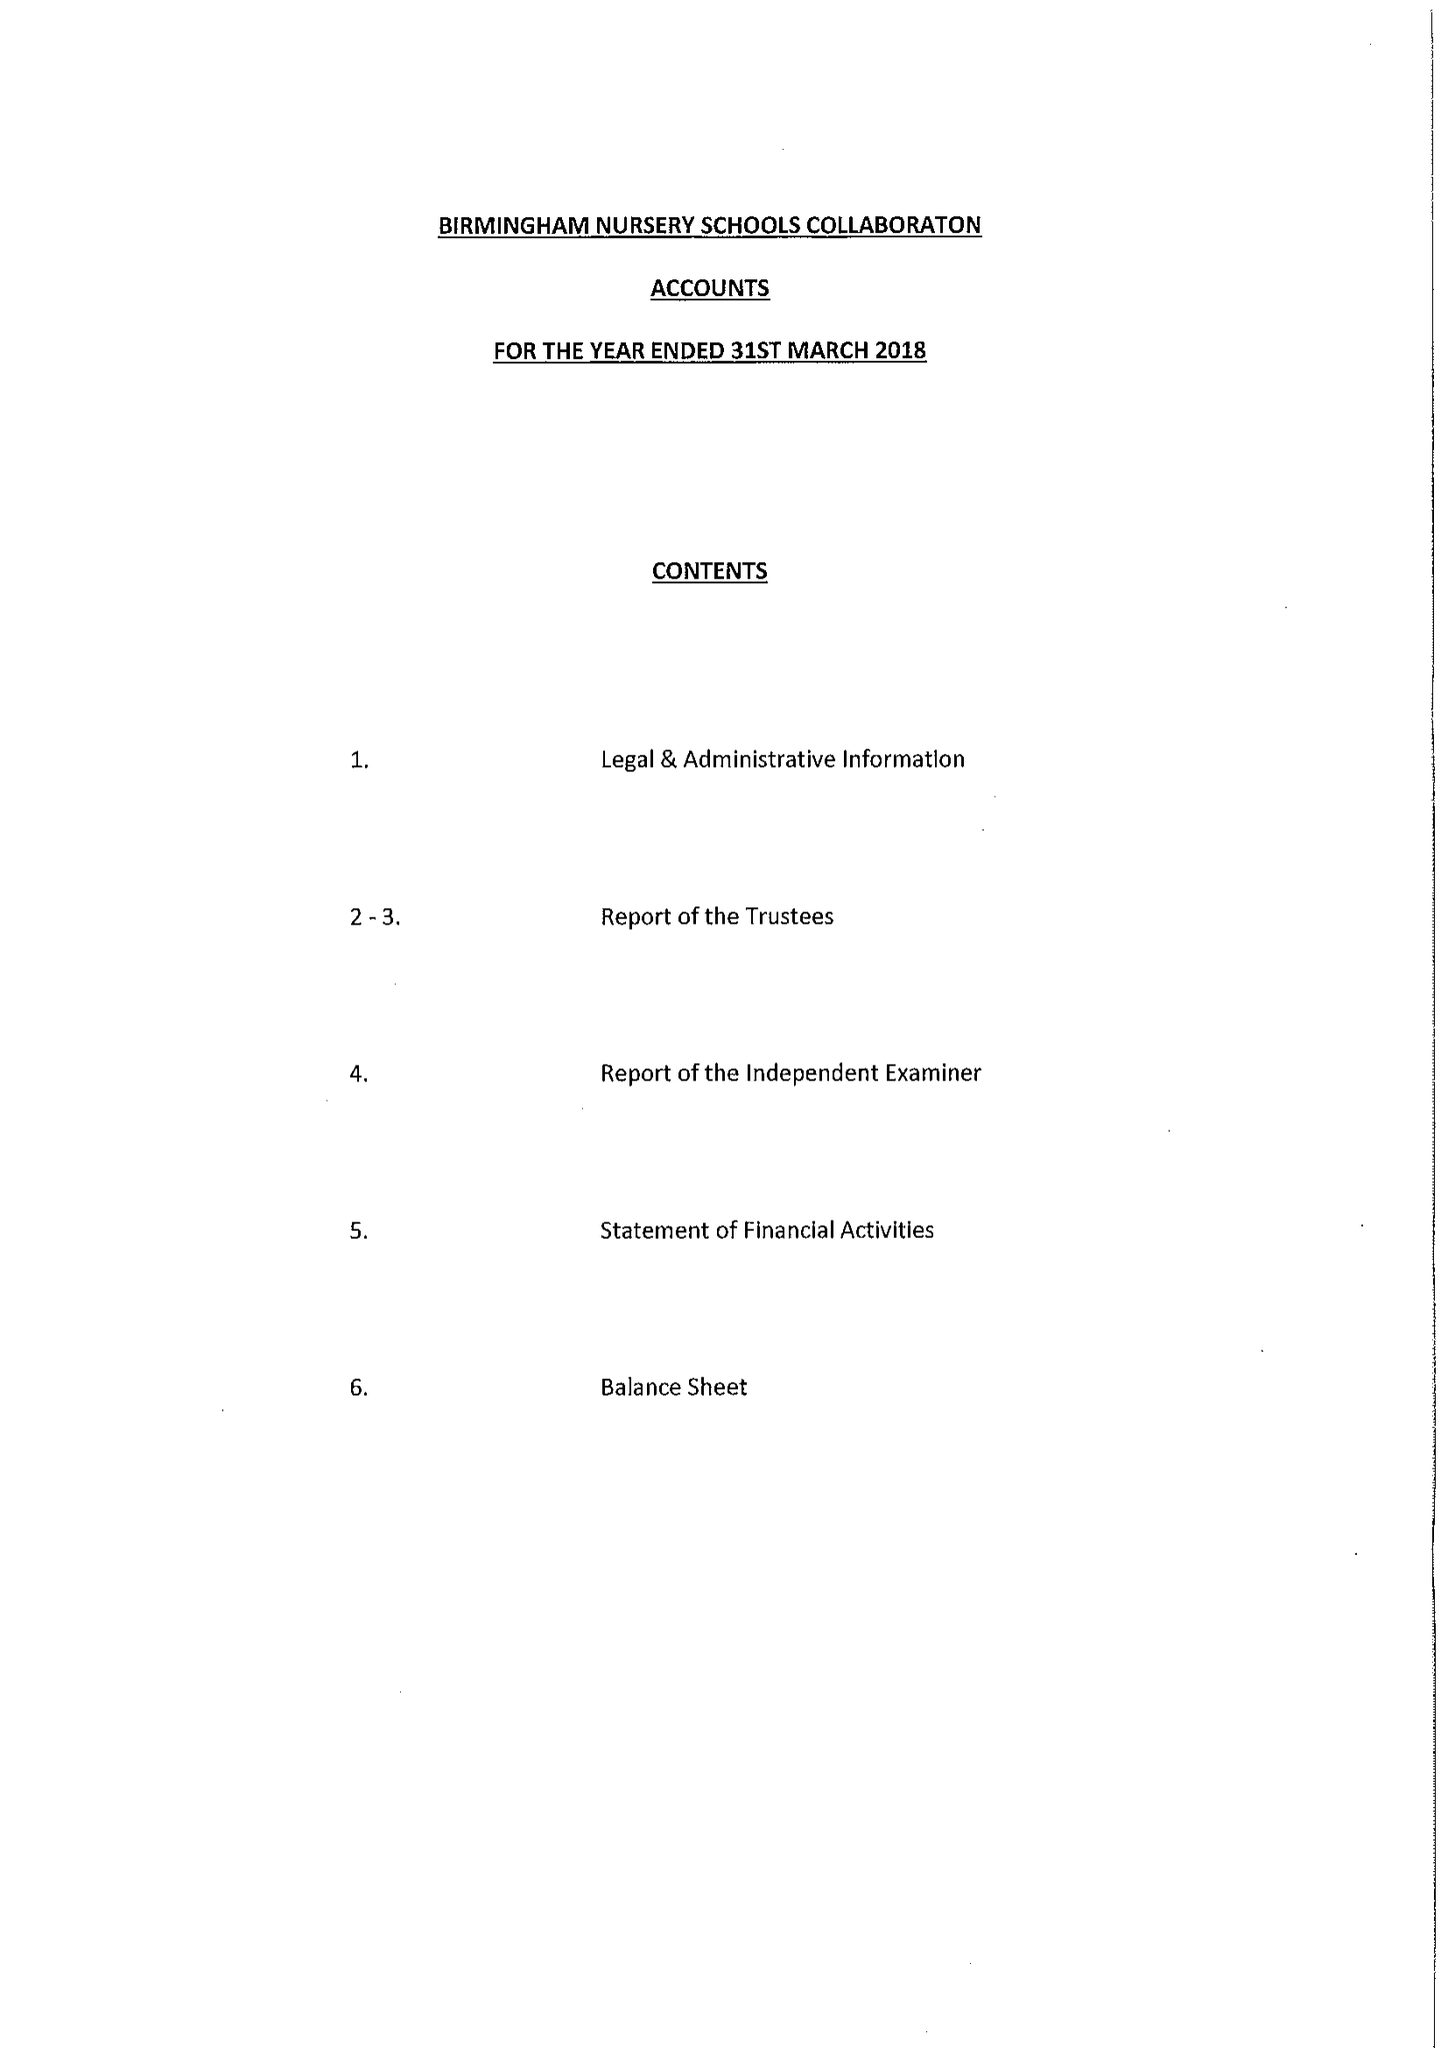What is the value for the address__street_line?
Answer the question using a single word or phrase. 358 BORDESLEY GREEN EAST 